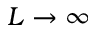Convert formula to latex. <formula><loc_0><loc_0><loc_500><loc_500>L \rightarrow \infty</formula> 